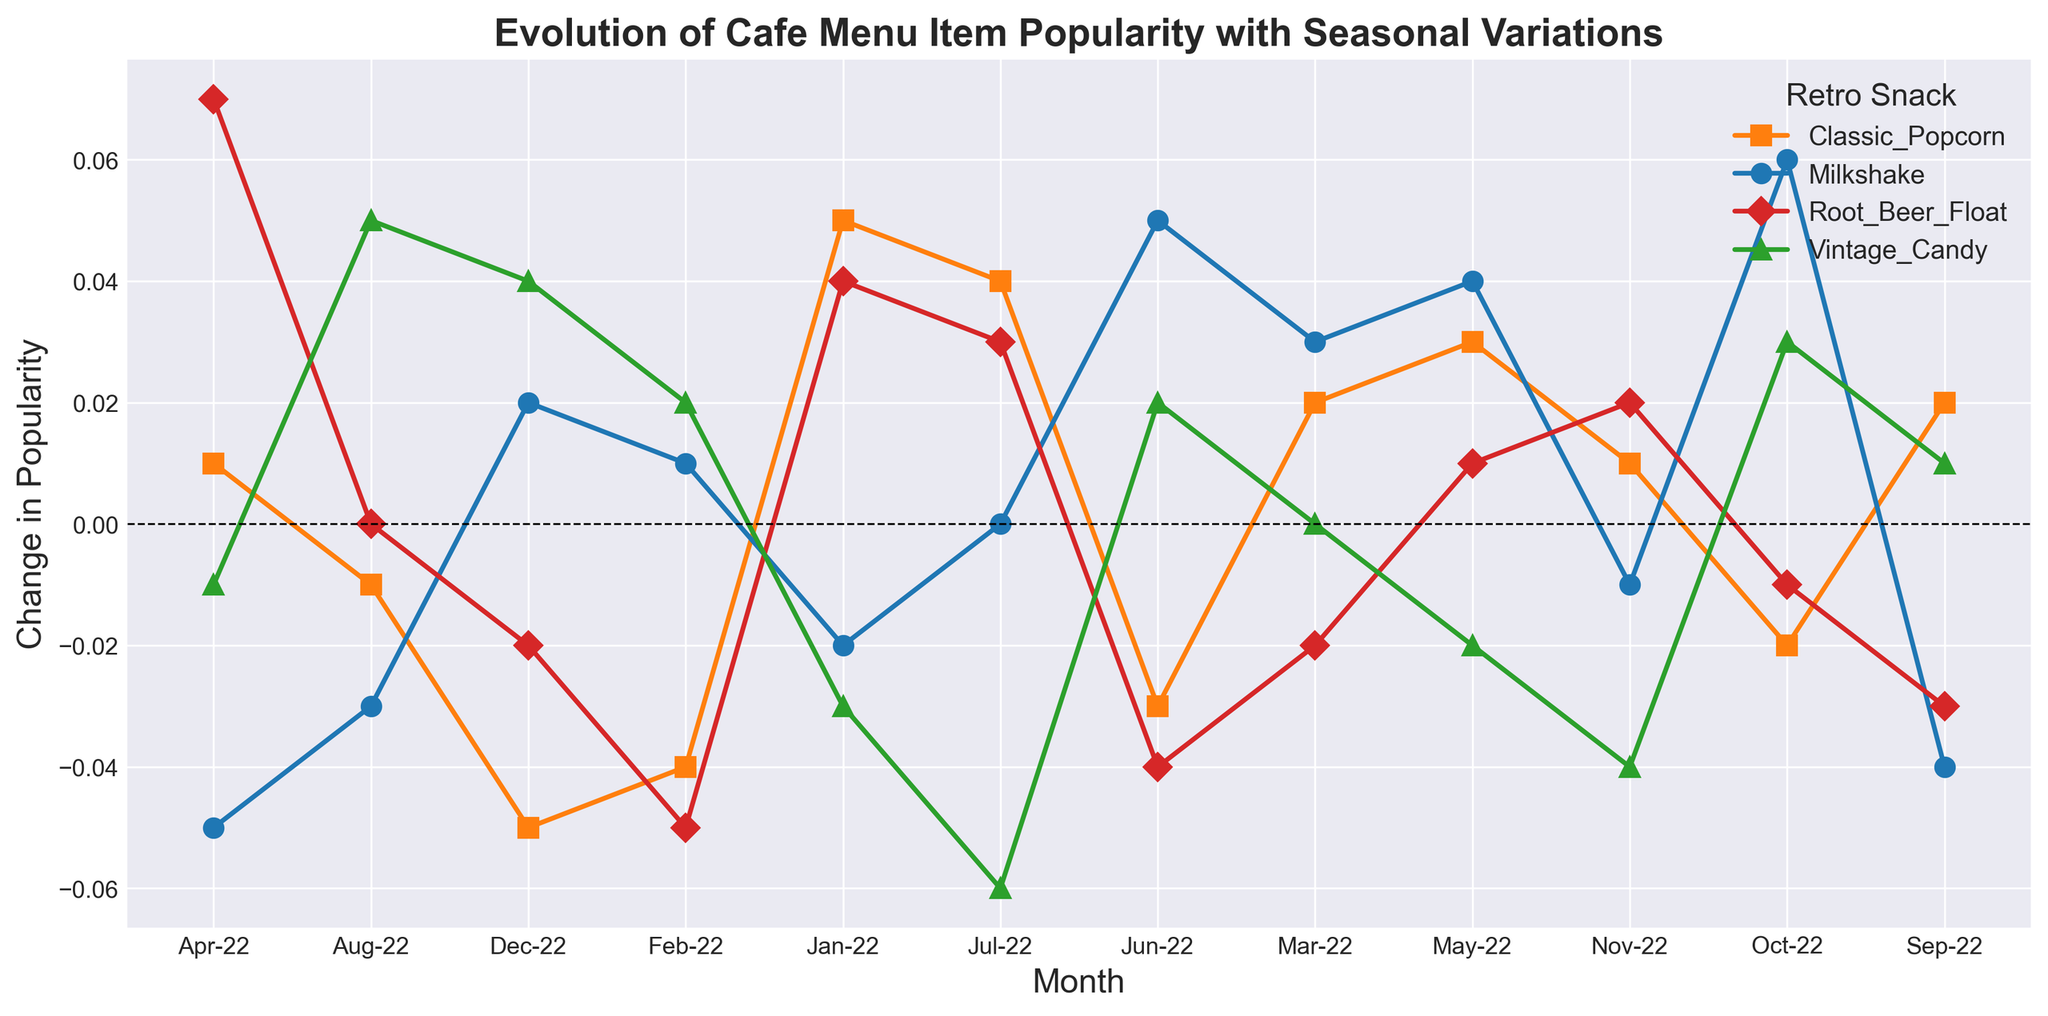What is the overall trend in popularity for Milkshakes throughout the year? To determine the overall trend, we look at the points for each month for Milkshakes. Jan-22: -0.02, Feb-22: 0.01, Mar-22: 0.03, Apr-22: -0.05, May-22: 0.04, Jun-22: 0.05, Jul-22: 0.00, Aug-22: -0.03, Sep-22: -0.04, Oct-22: 0.06, Nov-22: -0.01, Dec-22: 0.02. The trend shows initial fluctuations, a positive increase mid-year, a decline later, and a final rise.
Answer: Fluctuating with an eventual increase Which retro snack had the highest increase in popularity in any single month? To find the highest increase, we compare the positive changes in popularity for each month among all snacks. Root Beer Float in April-22 had a change of 0.07, which is the highest single-month increase.
Answer: Root Beer Float in April-22 How did the popularity of Root Beer Float change from February to March 2022? For Root Beer Float, the changes were Feb-22: -0.05 and Mar-22: -0.02. From Feb to Mar, the popularity increased by (-0.02) - (-0.05) = 0.03.
Answer: Increased by 0.03 Between Vintage Candy and Classic Popcorn, which had a higher net change in popularity over the whole year? Summing changes from Jan to Dec 2022: 
Vintage Candy: -0.03 + 0.02 + 0.00 -0.01 -0.02 + 0.02 -0.06 + 0.05 + 0.01 + 0.03 -0.04 + 0.04 = 0.01. 
Classic Popcorn: 0.05 -0.04 + 0.02 +0.01 + 0.03 -0.03 + 0.04 -0.01 + 0.02 -0.02 + 0.01 -0.05 = 0.03. Classic Popcorn has a higher net change.
Answer: Classic Popcorn How does the popularity of Classic Popcorn in December compare to January? For Classic Popcorn, Jan-22: 0.05 and Dec-22: -0.05. Comparing these values, we see a decrease from 0.05 to -0.05.
Answer: Decreased What color represents Vintage Candy in the chart? The colors are defined as:
Milkshake: blue,
Classic Popcorn: orange,
Vintage Candy: green,
Root Beer Float: red.
Vintage Candy is represented by the color green.
Answer: Green Which month experienced the most dramatic rise or fall in popularity for Milkshakes, and what was the value? We look for the highest absolute change in popularity for Milkshakes. The biggest change is in April-22: -0.05 (in terms of magnitude). Thus, the most dramatic fall is April-22 with a change of -0.05.
Answer: April-22, -0.05 Did Root Beer Float ever experience a net positive change over two consecutive months? Checking the changes for two consecutive months:
Feb to Mar (-0.05 to -0.02) gives -0.03 which is negative
Apr to May (0.07 to 0.01) gives -0.06 which is negative
Jun to Jul (-0.04 to 0.03) gives +0.07 which is positive
Sep to Oct (-0.03 to -0.01) gives +0.02 which is positive
The only time with a net positive change was from Jun to Jul and Sep to Oct.
Answer: Yes, Jun to Jul and Sep to Oct What was the popularity change of all snacks in October, combined? Summing the changes for all snacks in Oct-22: Milkshake: 0.06, Classic Popcorn: -0.02, Vintage Candy: 0.03, Root Beer Float: -0.01. Total = 0.06 - 0.02 + 0.03 - 0.01 = 0.06.
Answer: 0.06 What marker shape represents "Root Beer Float" in the chart? The markers are defined as follows:
Milkshake: 'o',
Classic Popcorn: 's',
Vintage Candy: '^',
Root Beer Float: 'D'.
Root Beer Float is represented by a diamond shape.
Answer: Diamond 